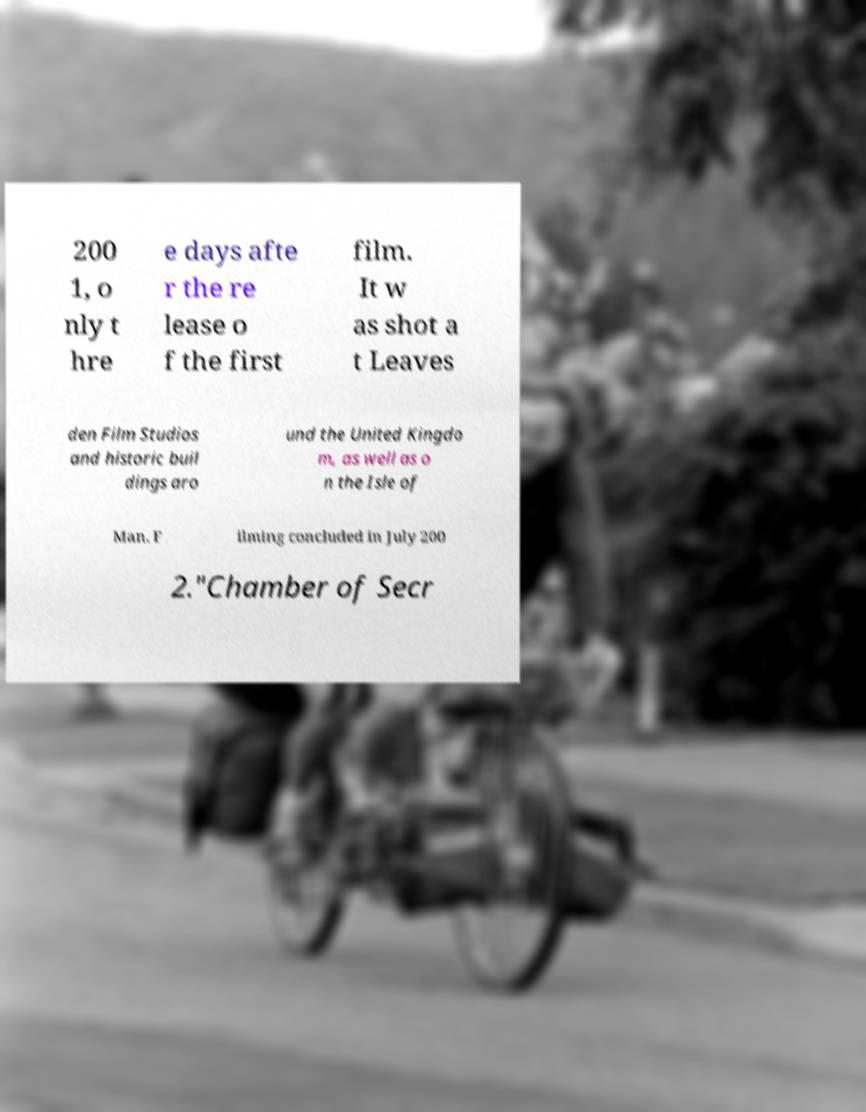Can you accurately transcribe the text from the provided image for me? 200 1, o nly t hre e days afte r the re lease o f the first film. It w as shot a t Leaves den Film Studios and historic buil dings aro und the United Kingdo m, as well as o n the Isle of Man. F ilming concluded in July 200 2."Chamber of Secr 